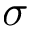Convert formula to latex. <formula><loc_0><loc_0><loc_500><loc_500>\sigma</formula> 